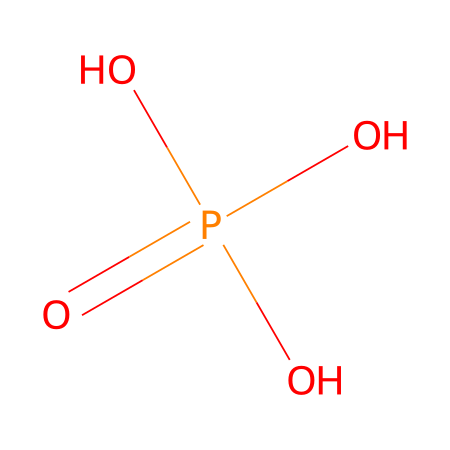What is the molecular formula of this acid? The SMILES representation indicates there are one phosphorus atom (P) and four oxygen atoms (O) in the structure, with the presence of three hydroxy groups (OH) attached to the phosphorus. Thus, the total comprises of H atoms that equal the number of hydroxy groups. This leads us to the molecular formula H3PO4.
Answer: H3PO4 How many oxygen atoms are present in this chemical? By analyzing the structure from the SMILES notation, we identify that there are four oxygen atoms directly linked in the molecular formula.
Answer: 4 What is the main use of phosphoric acid in the oil industry? Phosphoric acid is commonly used as a corrosion inhibitor in oil industry processes to protect pipelines and equipment from degradation.
Answer: corrosion inhibitor How many hydrogen atoms are in the phosphoric acid structure? In the SMILES representation, the three hydroxy groups (O-H) indicate the presence of three hydrogen atoms that are involved in acidic properties of the molecule.
Answer: 3 What type of acid is phosphoric acid considered? Given its properties and structure, phosphoric acid is classified as a weak acid due to its incomplete dissociation in solution.
Answer: weak acid Which functional groups are present in phosphoric acid? The presence of three hydroxyl (-OH) groups and a phosphorus atom indicates that the functional groups in phosphoric acid are hydroxyl groups which contribute to its acidic nature.
Answer: hydroxyl groups Is this acid a strong acid? Phosphoric acid is known to be a weak acid because it does not completely ionize in solution, and thus is not categorized among strong acids.
Answer: weak 